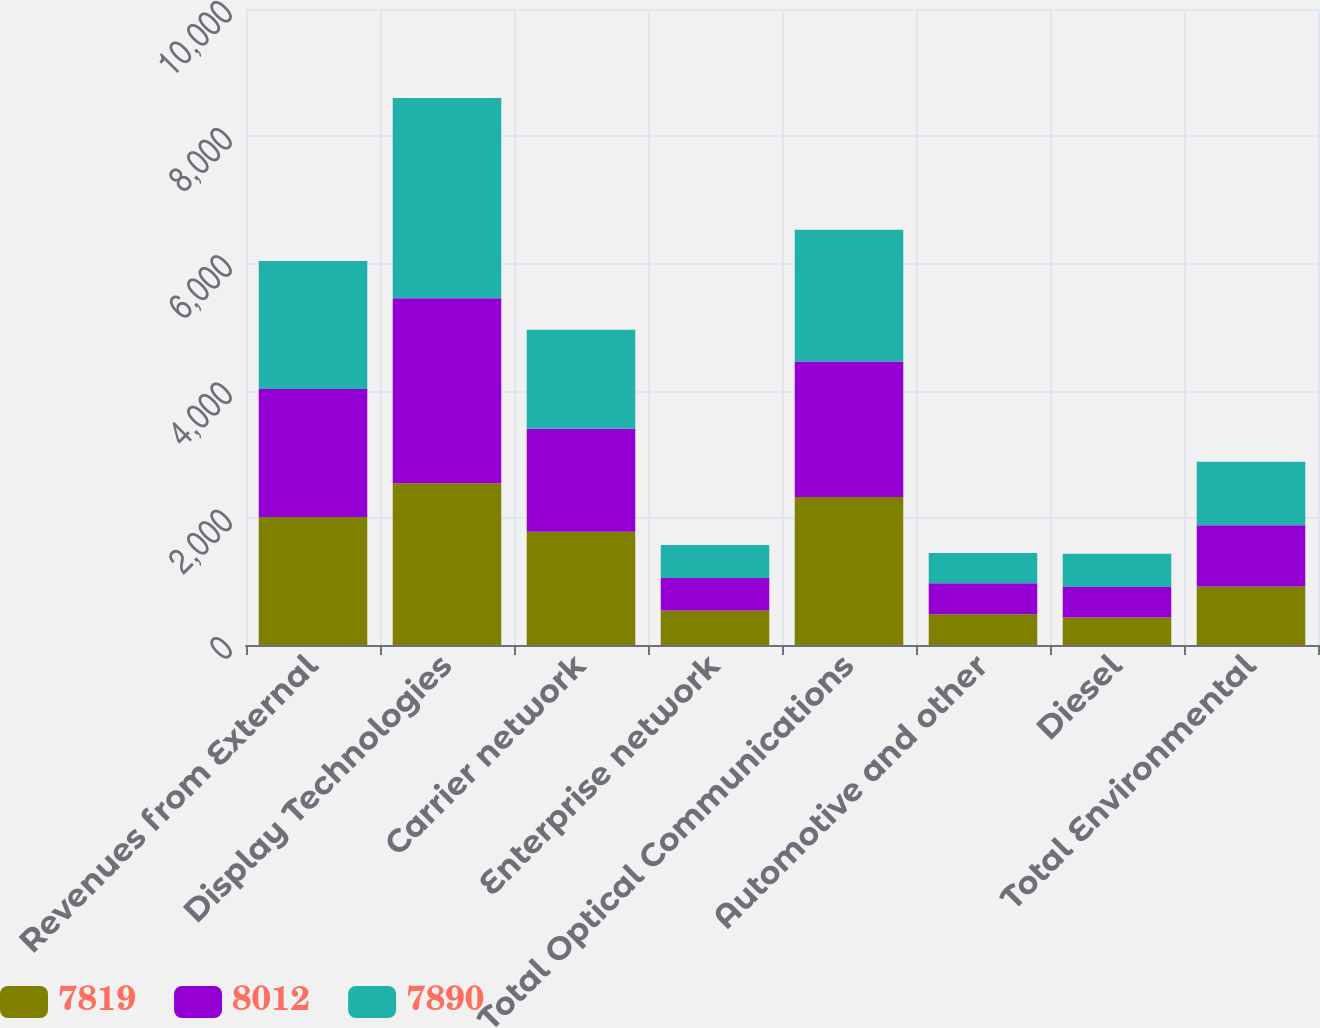Convert chart to OTSL. <chart><loc_0><loc_0><loc_500><loc_500><stacked_bar_chart><ecel><fcel>Revenues from External<fcel>Display Technologies<fcel>Carrier network<fcel>Enterprise network<fcel>Total Optical Communications<fcel>Automotive and other<fcel>Diesel<fcel>Total Environmental<nl><fcel>7819<fcel>2013<fcel>2545<fcel>1782<fcel>544<fcel>2326<fcel>485<fcel>434<fcel>919<nl><fcel>8012<fcel>2012<fcel>2909<fcel>1619<fcel>511<fcel>2130<fcel>486<fcel>478<fcel>964<nl><fcel>7890<fcel>2011<fcel>3145<fcel>1556<fcel>516<fcel>2072<fcel>476<fcel>522<fcel>998<nl></chart> 